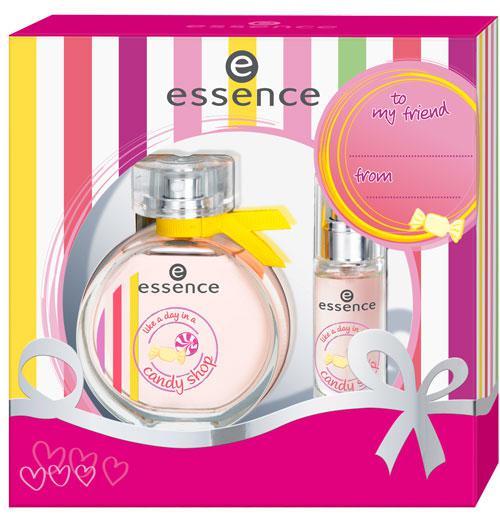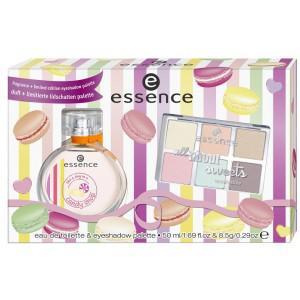The first image is the image on the left, the second image is the image on the right. Given the left and right images, does the statement "Both images show a circular perfume bottle next to a candy-striped box." hold true? Answer yes or no. No. 